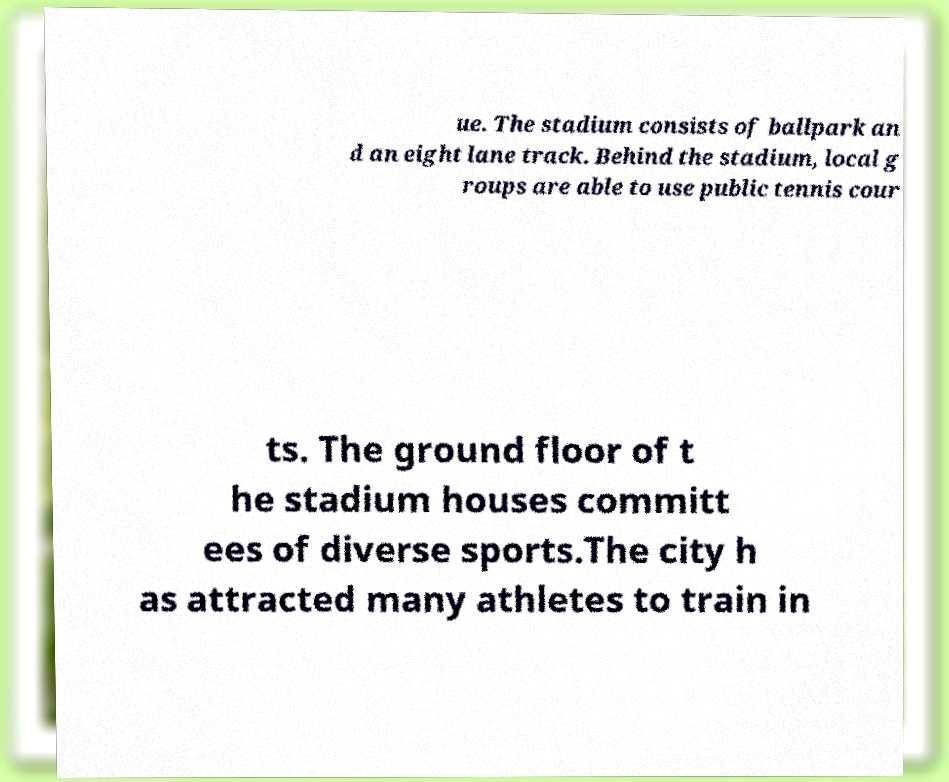Can you accurately transcribe the text from the provided image for me? ue. The stadium consists of ballpark an d an eight lane track. Behind the stadium, local g roups are able to use public tennis cour ts. The ground floor of t he stadium houses committ ees of diverse sports.The city h as attracted many athletes to train in 